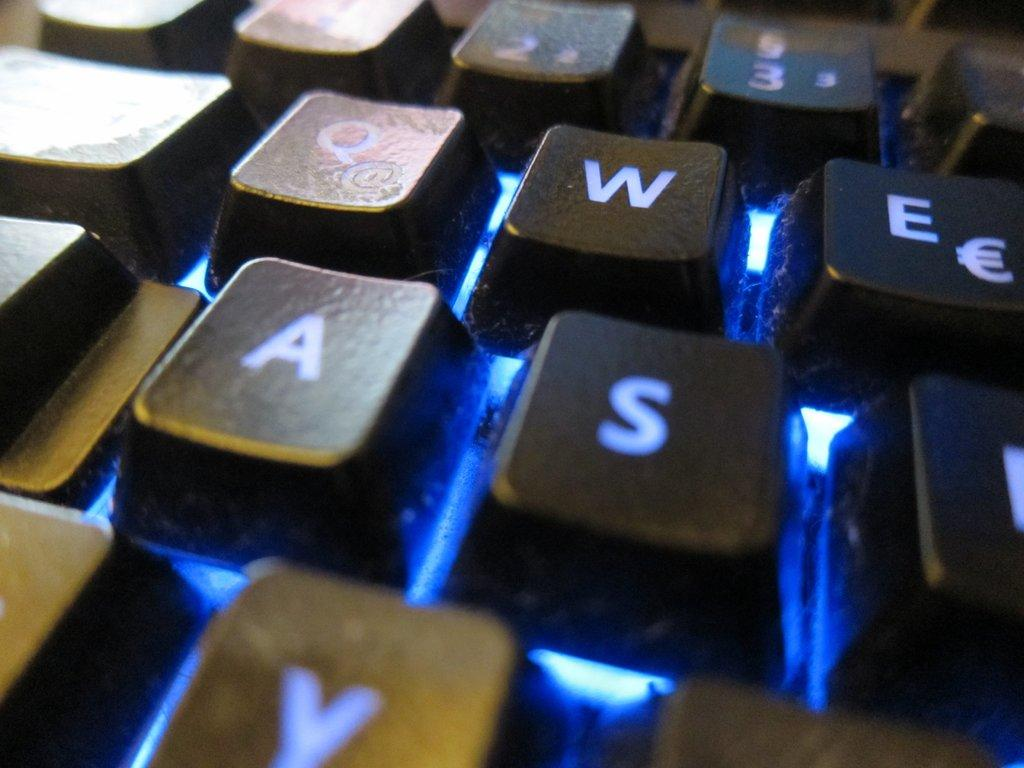<image>
Share a concise interpretation of the image provided. A keyboard with the letters W, E, A, S are visible 